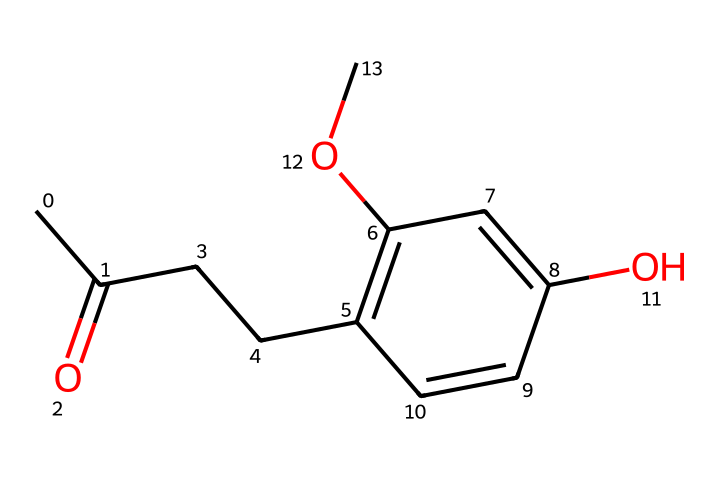What is the molecular formula of raspberry ketone? By analyzing the SMILES representation, we can deduce the molecular formula. The structure contains 10 carbon atoms, 10 hydrogen atoms, and 3 oxygen atoms, leading to a molecular formula of C10H10O3.
Answer: C10H10O3 How many hydroxyl groups are present in raspberry ketone? From the structural formula derived from the SMILES notation, we can identify one hydroxyl group (-OH) attached to the aromatic ring of the compound.
Answer: one What functional group characterizes raspberry ketone? The defining feature of a ketone is the carbonyl group (C=O). In the structure, there is a carbonyl group indicated by the carbon double bonded to an oxygen atom.
Answer: carbonyl group What is the total number of double bonds in raspberry ketone? Upon reviewing the SMILES structure, we see there is one double bond in the carbonyl functional group and three double bonds in the aromatic portion of the molecule, totaling four double bonds present.
Answer: four Does raspberry ketone contain a cyclic structure? The presence of a ring-like structure in the chemical representation indicates that raspberry ketone contains a cyclic structure, specifically a phenolic ring.
Answer: yes What is the carbon count in the longest carbon chain of raspberry ketone? By examining the SMILES structure, the longest carbon chain can be seen comprising five carbons, which connects the carbonyl to the aromatic group.
Answer: five 